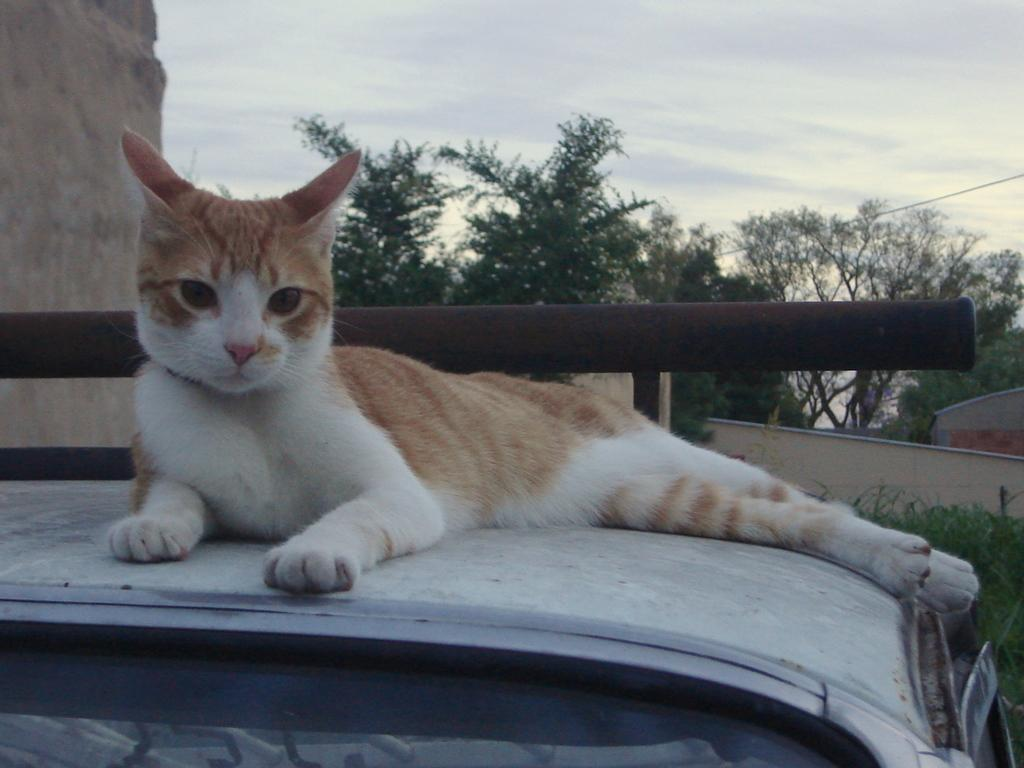What is the main subject in the image? There is a vehicle in the image. Can you describe the position of the cat in relation to the vehicle? The cat is above the vehicle. What can be seen in the background of the image? The sky, trees, walls, and a rod are visible in the background of the image. How many beds are visible in the image? There are no beds present in the image. What word is being spelled out by the cattle in the image? There are no cattle or words present in the image. 